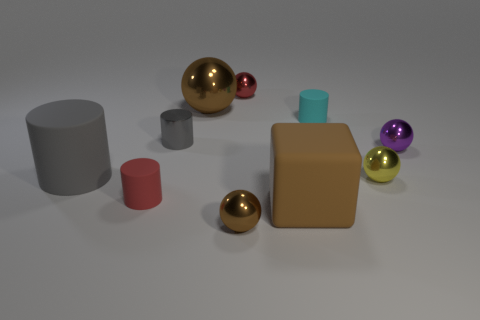Is the large matte block the same color as the big sphere?
Keep it short and to the point. Yes. What number of big balls are the same color as the rubber block?
Ensure brevity in your answer.  1. The large matte object that is the same shape as the tiny gray thing is what color?
Provide a succinct answer. Gray. How many shiny objects are tiny brown things or small gray cylinders?
Your response must be concise. 2. What number of tiny cyan matte objects are there?
Your answer should be very brief. 1. What color is the other rubber cylinder that is the same size as the red cylinder?
Offer a terse response. Cyan. Is the gray shiny thing the same size as the gray matte cylinder?
Your answer should be compact. No. What shape is the rubber object that is the same color as the big metal object?
Provide a succinct answer. Cube. There is a yellow metal sphere; does it have the same size as the metal object in front of the yellow shiny thing?
Offer a terse response. Yes. The object that is on the left side of the small cyan rubber cylinder and on the right side of the red metallic sphere is what color?
Your response must be concise. Brown. 